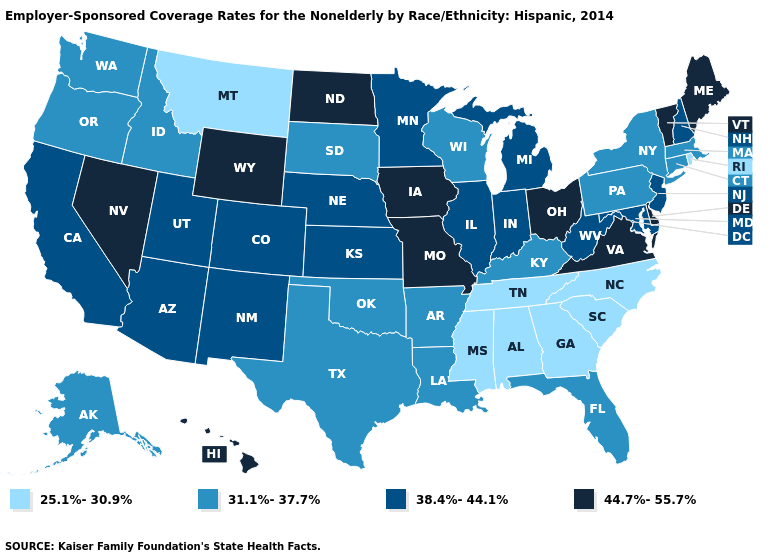What is the value of Hawaii?
Answer briefly. 44.7%-55.7%. Name the states that have a value in the range 44.7%-55.7%?
Give a very brief answer. Delaware, Hawaii, Iowa, Maine, Missouri, Nevada, North Dakota, Ohio, Vermont, Virginia, Wyoming. Name the states that have a value in the range 31.1%-37.7%?
Short answer required. Alaska, Arkansas, Connecticut, Florida, Idaho, Kentucky, Louisiana, Massachusetts, New York, Oklahoma, Oregon, Pennsylvania, South Dakota, Texas, Washington, Wisconsin. Among the states that border Vermont , which have the lowest value?
Give a very brief answer. Massachusetts, New York. What is the value of New Jersey?
Short answer required. 38.4%-44.1%. What is the highest value in states that border Wyoming?
Quick response, please. 38.4%-44.1%. What is the value of South Carolina?
Give a very brief answer. 25.1%-30.9%. Does Montana have the lowest value in the West?
Answer briefly. Yes. Name the states that have a value in the range 31.1%-37.7%?
Concise answer only. Alaska, Arkansas, Connecticut, Florida, Idaho, Kentucky, Louisiana, Massachusetts, New York, Oklahoma, Oregon, Pennsylvania, South Dakota, Texas, Washington, Wisconsin. What is the value of California?
Be succinct. 38.4%-44.1%. Among the states that border Connecticut , which have the lowest value?
Be succinct. Rhode Island. Name the states that have a value in the range 25.1%-30.9%?
Be succinct. Alabama, Georgia, Mississippi, Montana, North Carolina, Rhode Island, South Carolina, Tennessee. Name the states that have a value in the range 38.4%-44.1%?
Quick response, please. Arizona, California, Colorado, Illinois, Indiana, Kansas, Maryland, Michigan, Minnesota, Nebraska, New Hampshire, New Jersey, New Mexico, Utah, West Virginia. What is the highest value in the MidWest ?
Write a very short answer. 44.7%-55.7%. 